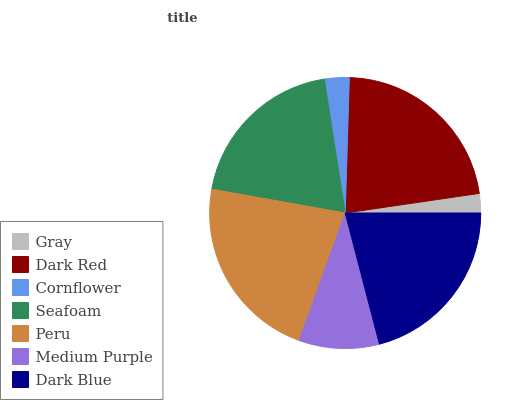Is Gray the minimum?
Answer yes or no. Yes. Is Peru the maximum?
Answer yes or no. Yes. Is Dark Red the minimum?
Answer yes or no. No. Is Dark Red the maximum?
Answer yes or no. No. Is Dark Red greater than Gray?
Answer yes or no. Yes. Is Gray less than Dark Red?
Answer yes or no. Yes. Is Gray greater than Dark Red?
Answer yes or no. No. Is Dark Red less than Gray?
Answer yes or no. No. Is Seafoam the high median?
Answer yes or no. Yes. Is Seafoam the low median?
Answer yes or no. Yes. Is Gray the high median?
Answer yes or no. No. Is Peru the low median?
Answer yes or no. No. 